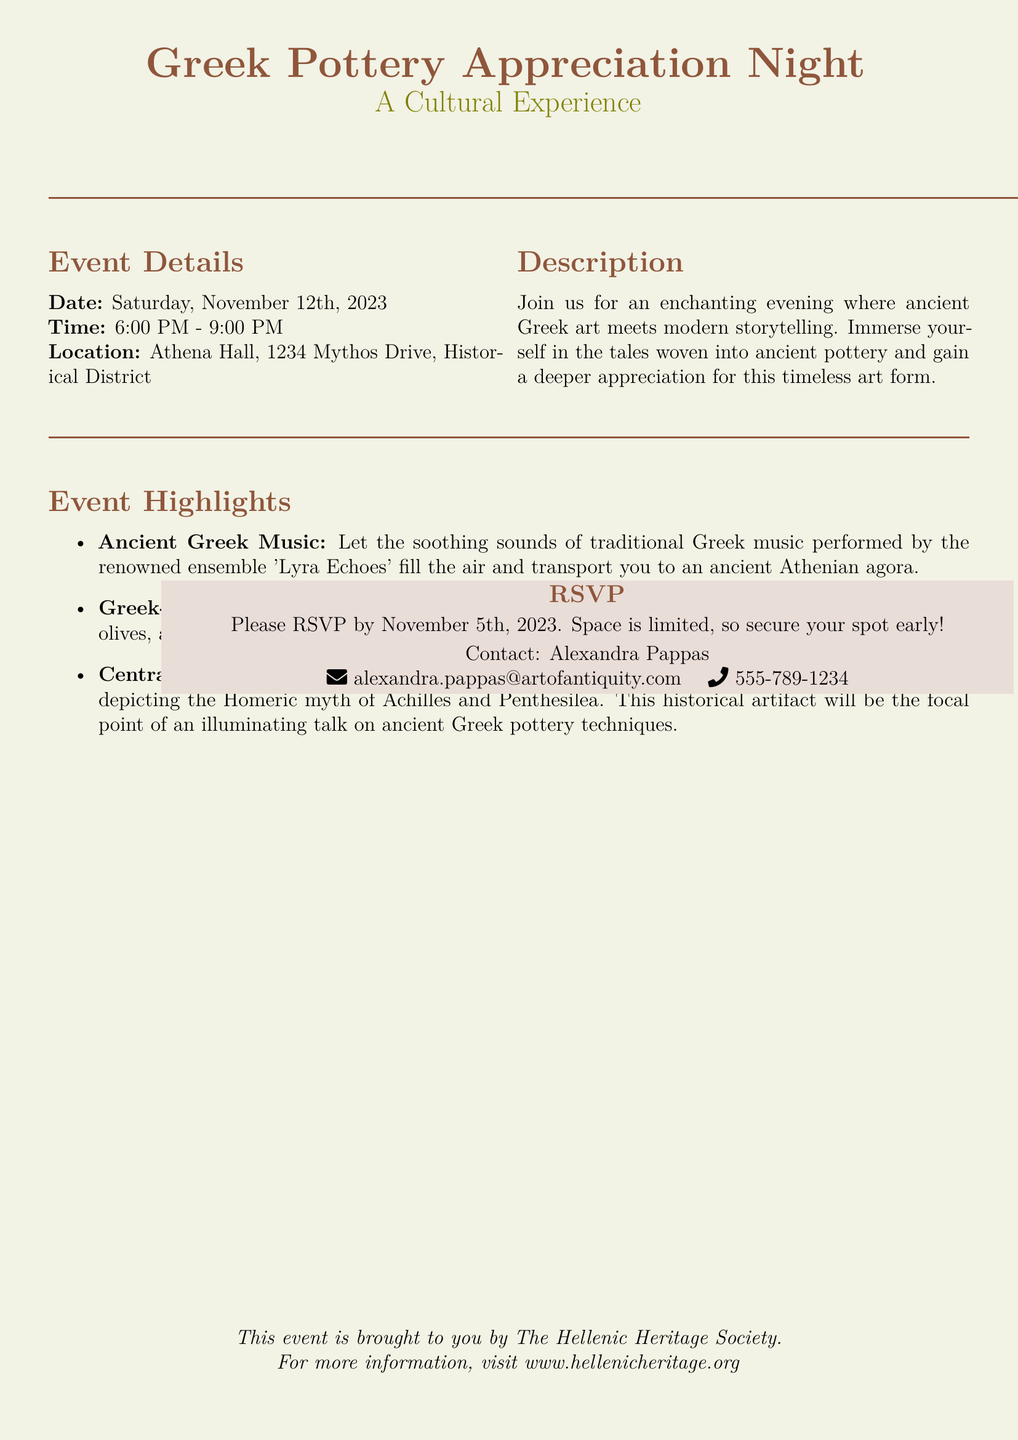what is the date of the event? The date is specifically stated in the event details section of the document as Saturday, November 12th, 2023.
Answer: November 12th, 2023 what is the location of the event? The location is given in the event details section as Athena Hall, 1234 Mythos Drive, Historical District.
Answer: Athena Hall, 1234 Mythos Drive, Historical District who is the contact person for RSVPs? The contact person is mentioned in the RSVP section as Alexandra Pappas, who is responsible for managing attendees.
Answer: Alexandra Pappas what type of music will be performed at the event? The event highlights section specifies that traditional Greek music will be performed by the ensemble 'Lyra Echoes'.
Answer: traditional Greek music how long does the event last? The time frame given in the event details indicates the start at 6:00 PM and the end at 9:00 PM, making the duration three hours.
Answer: 3 hours what should attendees do to secure their spot? The RSVP section instructs attendees to respond by a certain date due to limited space, indicating a need for early action.
Answer: RSVP by November 5th, 2023 what is the main focus of the evening's centerpiece? The description of the central amphora in the event highlights outlines that it depicts the Homeric myth of Achilles and Penthesilea.
Answer: Achilles and Penthesilea what type of refreshments will be served? The event highlights detail that guests can savor Greek-inspired refreshments such as dolmades and baklava, linking these treats to ancient Greek culture.
Answer: Greek-inspired refreshments what organization is hosting the event? The document concludes with information about the event's organizer, specifically identifying them as The Hellenic Heritage Society.
Answer: The Hellenic Heritage Society 